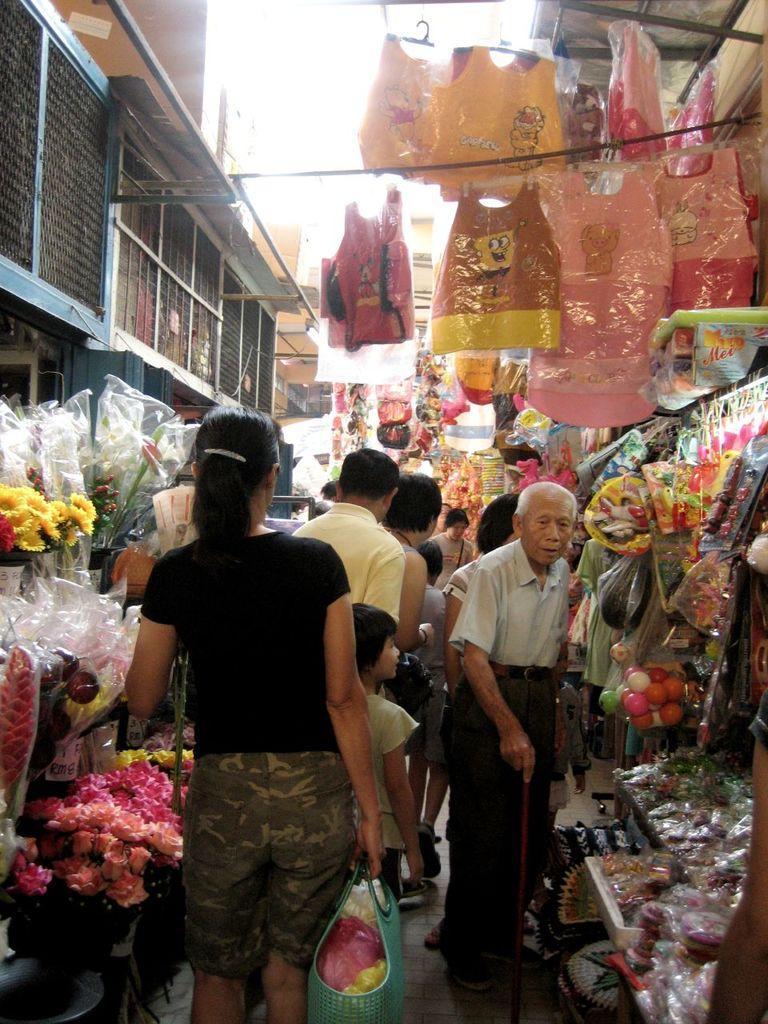How would you summarize this image in a sentence or two? It seems to be a stall. Here I can see many people are walking on the floor. One woman is carrying a basket in the hand. On the right and left side of the image I can see the flower bouquets, toys, balls, jackets and many other objects arranged on the tables. In the background there are many buildings. At the top of the image I can see the sky. 